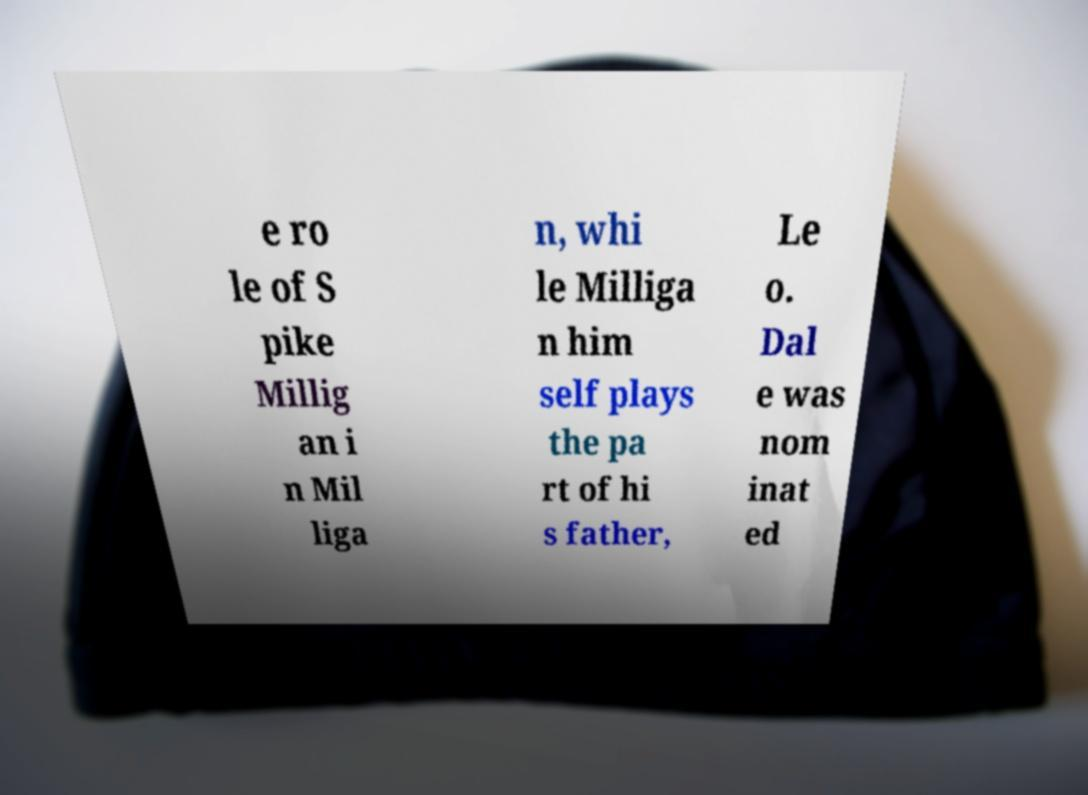Can you accurately transcribe the text from the provided image for me? e ro le of S pike Millig an i n Mil liga n, whi le Milliga n him self plays the pa rt of hi s father, Le o. Dal e was nom inat ed 